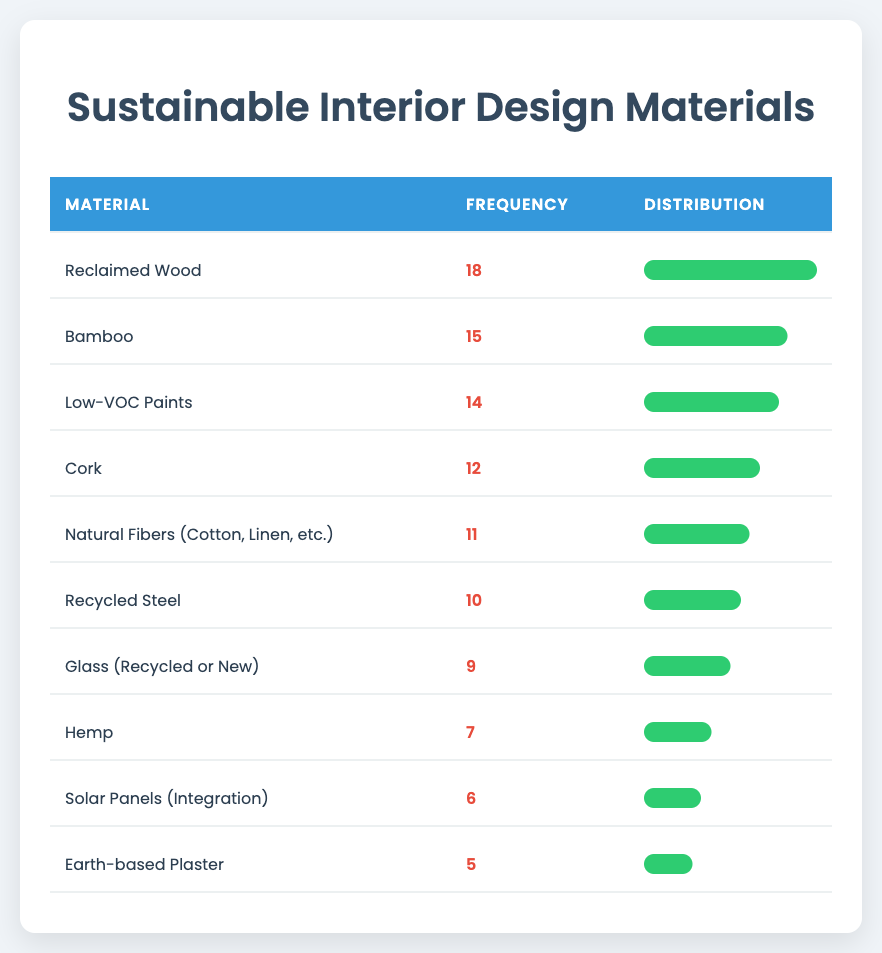What is the most frequently used sustainable material? The table shows "Reclaimed Wood" with a frequency of 18, which is the highest compared to other materials listed.
Answer: Reclaimed Wood How many materials have a frequency greater than 10? By observing the table, the materials with a frequency greater than 10 are Reclaimed Wood (18), Bamboo (15), Low-VOC Paints (14), and Cork (12), totaling 4 materials.
Answer: 4 What is the frequency of Glass compared to Hemp? Glass has a frequency of 9 and Hemp has a frequency of 7. Glass is greater than Hemp by 2.
Answer: Glass has 2 more frequencies than Hemp Are there any sustainable materials with a frequency of less than 10? The table lists Hemp (7), Solar Panels (6), and Earth-based Plaster (5), showing that there are materials with a frequency of less than 10.
Answer: Yes What is the difference in frequency between Bamboo and Low-VOC Paints? Bamboo has a frequency of 15 while Low-VOC Paints has a frequency of 14. The difference is calculated by subtracting 14 from 15, which equals 1.
Answer: 1 Which material has the second highest frequency, and what is its value? The first highest frequency is 18 for Reclaimed Wood. The second highest frequency is 15 for Bamboo, as it is the next highest after 18.
Answer: Bamboo, 15 What percentage of materials registered a frequency of 10 or more? There are 6 materials with a frequency of 10 or more (Reclaimed Wood, Bamboo, Low-VOC Paints, Cork, Natural Fibers, Recycled Steel), with 10 materials in total. To find the percentage: (6/10) * 100 = 60%.
Answer: 60% If we combine the frequencies of Hemp and Earth-based Plaster, what is the total? Hemp has a frequency of 7, and Earth-based Plaster has a frequency of 5. The total is found by summing 7 and 5, which equals 12.
Answer: 12 